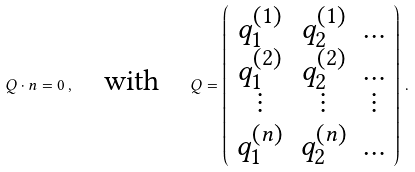Convert formula to latex. <formula><loc_0><loc_0><loc_500><loc_500>Q \cdot n = 0 \, , \quad \text {with} \quad Q = \left ( \begin{array} { c c c } q _ { 1 } ^ { ( 1 ) } & q _ { 2 } ^ { ( 1 ) } & \dots \\ q _ { 1 } ^ { ( 2 ) } & q _ { 2 } ^ { ( 2 ) } & \dots \\ \vdots & \vdots & \vdots \\ q _ { 1 } ^ { ( n ) } & q _ { 2 } ^ { ( n ) } & \dots \\ \end{array} \right ) \, .</formula> 